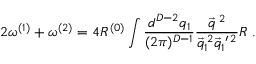<formula> <loc_0><loc_0><loc_500><loc_500>2 \omega ^ { ( 1 ) } + \omega ^ { ( 2 ) } = 4 R ^ { ( 0 ) } \int \frac { d ^ { D - 2 } q _ { 1 } } { ( 2 \pi ) ^ { D - 1 } } \frac { \vec { q } ^ { \, 2 } } { \vec { q } _ { 1 } ^ { \, 2 } \vec { q } _ { 1 } ^ { \, \prime \, 2 } } R \, .</formula> 